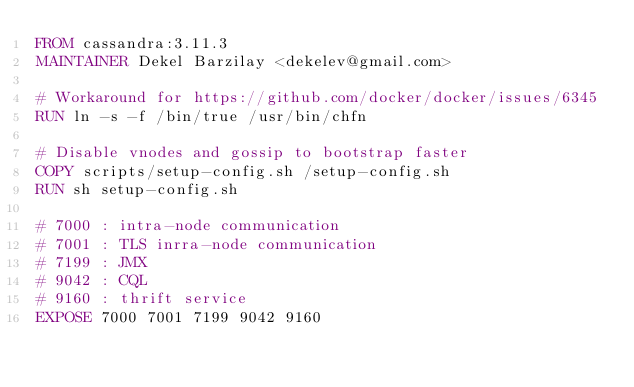Convert code to text. <code><loc_0><loc_0><loc_500><loc_500><_Dockerfile_>FROM cassandra:3.11.3
MAINTAINER Dekel Barzilay <dekelev@gmail.com>

# Workaround for https://github.com/docker/docker/issues/6345
RUN ln -s -f /bin/true /usr/bin/chfn

# Disable vnodes and gossip to bootstrap faster 
COPY scripts/setup-config.sh /setup-config.sh
RUN sh setup-config.sh

# 7000 : intra-node communication
# 7001 : TLS inrra-node communication
# 7199 : JMX
# 9042 : CQL
# 9160 : thrift service
EXPOSE 7000 7001 7199 9042 9160
</code> 